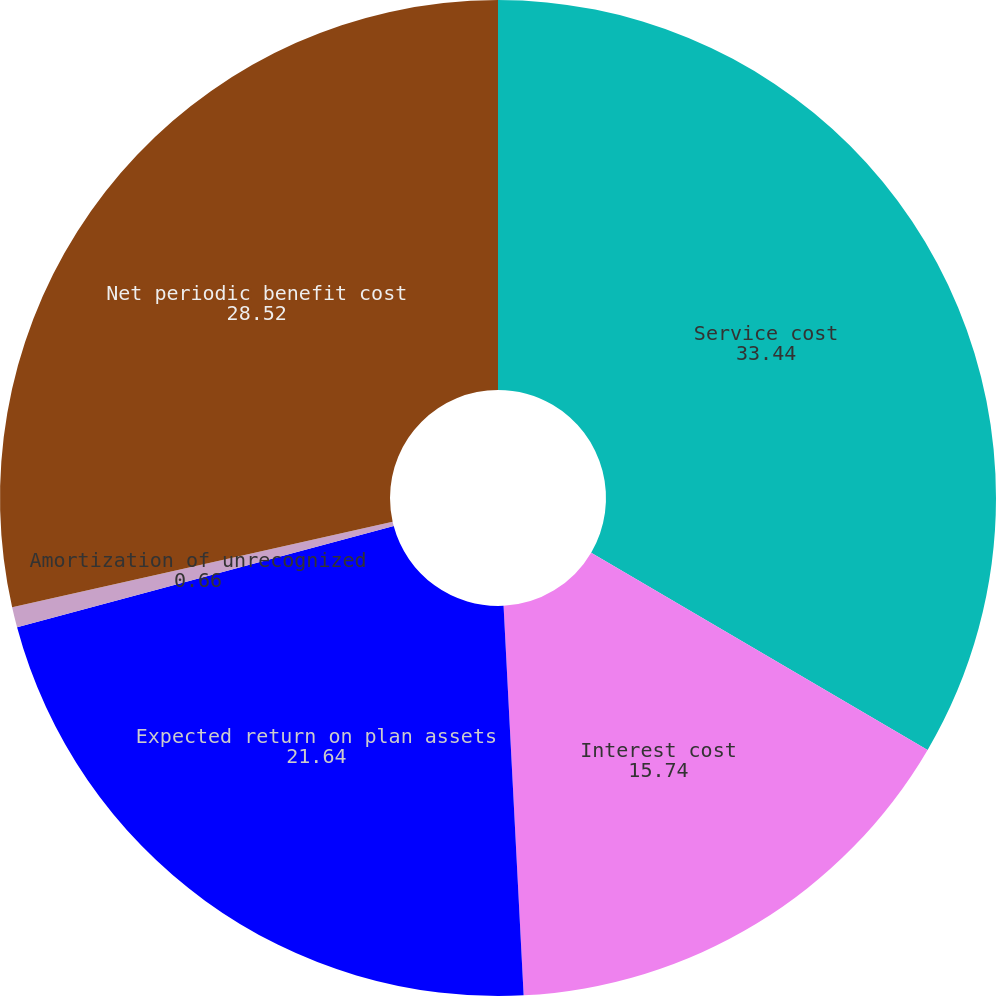<chart> <loc_0><loc_0><loc_500><loc_500><pie_chart><fcel>Service cost<fcel>Interest cost<fcel>Expected return on plan assets<fcel>Amortization of unrecognized<fcel>Net periodic benefit cost<nl><fcel>33.44%<fcel>15.74%<fcel>21.64%<fcel>0.66%<fcel>28.52%<nl></chart> 